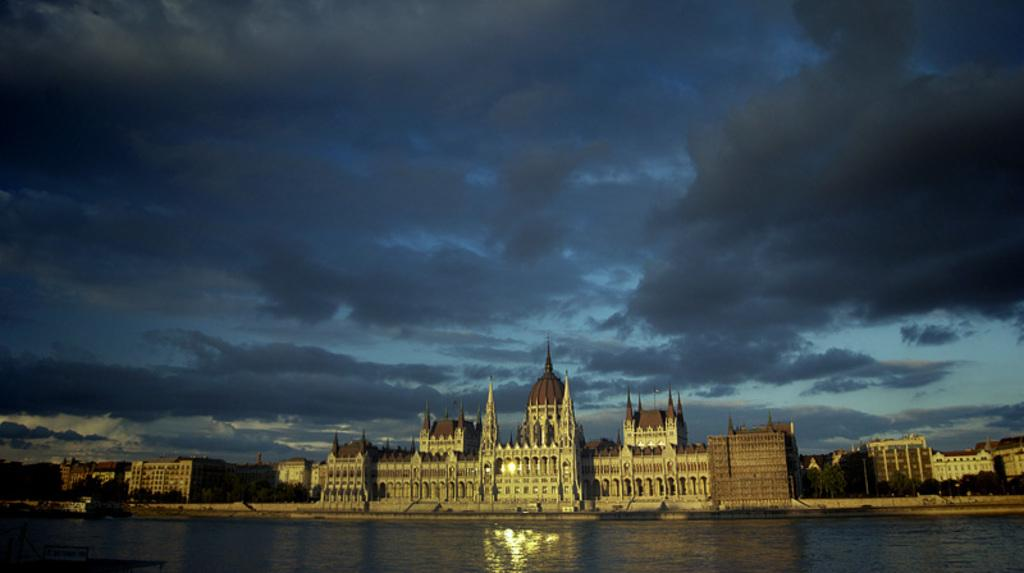What can be seen in the image that is not solid? There is water visible in the image. What type of structures are present in the image? There are buildings in the image. What type of vegetation is present in the image? There are trees in the image. What is visible in the background of the image? The sky is visible in the background of the image. What type of verse can be seen written on the trees in the image? There is no verse written on the trees in the image; it only features trees, buildings, water, and the sky. How many potatoes are visible in the image? There are no potatoes present in the image. 